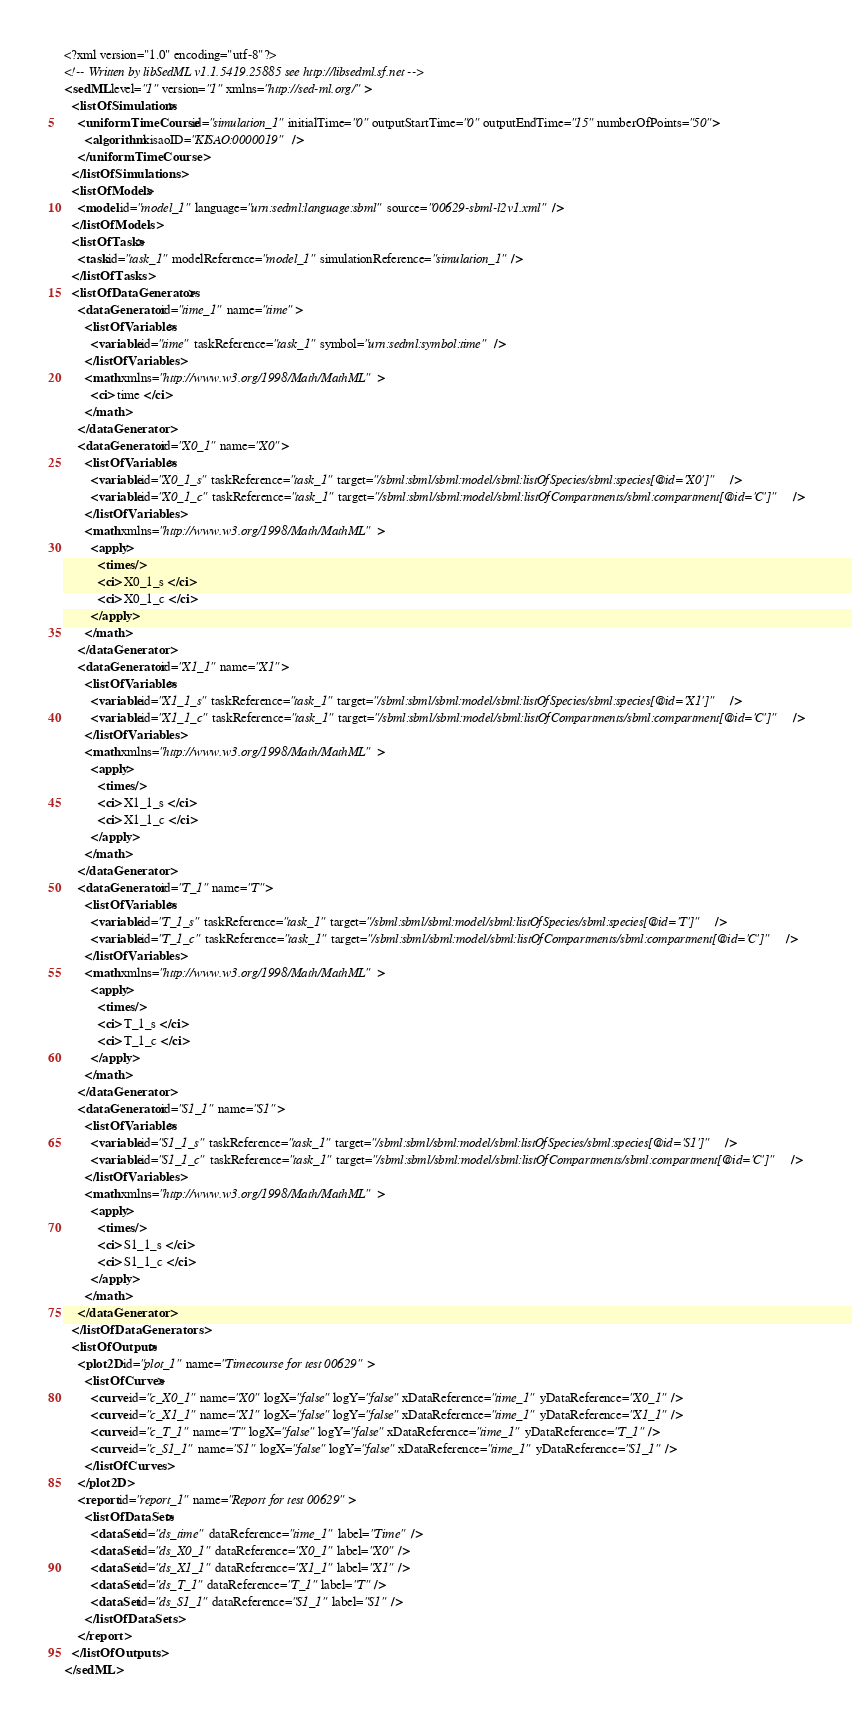Convert code to text. <code><loc_0><loc_0><loc_500><loc_500><_XML_><?xml version="1.0" encoding="utf-8"?>
<!-- Written by libSedML v1.1.5419.25885 see http://libsedml.sf.net -->
<sedML level="1" version="1" xmlns="http://sed-ml.org/">
  <listOfSimulations>
    <uniformTimeCourse id="simulation_1" initialTime="0" outputStartTime="0" outputEndTime="15" numberOfPoints="50">
      <algorithm kisaoID="KISAO:0000019" />
    </uniformTimeCourse>
  </listOfSimulations>
  <listOfModels>
    <model id="model_1" language="urn:sedml:language:sbml" source="00629-sbml-l2v1.xml" />
  </listOfModels>
  <listOfTasks>
    <task id="task_1" modelReference="model_1" simulationReference="simulation_1" />
  </listOfTasks>
  <listOfDataGenerators>
    <dataGenerator id="time_1" name="time">
      <listOfVariables>
        <variable id="time" taskReference="task_1" symbol="urn:sedml:symbol:time" />
      </listOfVariables>
      <math xmlns="http://www.w3.org/1998/Math/MathML">
        <ci> time </ci>
      </math>
    </dataGenerator>
    <dataGenerator id="X0_1" name="X0">
      <listOfVariables>
        <variable id="X0_1_s" taskReference="task_1" target="/sbml:sbml/sbml:model/sbml:listOfSpecies/sbml:species[@id='X0']" />
        <variable id="X0_1_c" taskReference="task_1" target="/sbml:sbml/sbml:model/sbml:listOfCompartments/sbml:compartment[@id='C']" />
      </listOfVariables>
      <math xmlns="http://www.w3.org/1998/Math/MathML">
        <apply>
          <times />
          <ci> X0_1_s </ci>
          <ci> X0_1_c </ci>
        </apply>
      </math>
    </dataGenerator>
    <dataGenerator id="X1_1" name="X1">
      <listOfVariables>
        <variable id="X1_1_s" taskReference="task_1" target="/sbml:sbml/sbml:model/sbml:listOfSpecies/sbml:species[@id='X1']" />
        <variable id="X1_1_c" taskReference="task_1" target="/sbml:sbml/sbml:model/sbml:listOfCompartments/sbml:compartment[@id='C']" />
      </listOfVariables>
      <math xmlns="http://www.w3.org/1998/Math/MathML">
        <apply>
          <times />
          <ci> X1_1_s </ci>
          <ci> X1_1_c </ci>
        </apply>
      </math>
    </dataGenerator>
    <dataGenerator id="T_1" name="T">
      <listOfVariables>
        <variable id="T_1_s" taskReference="task_1" target="/sbml:sbml/sbml:model/sbml:listOfSpecies/sbml:species[@id='T']" />
        <variable id="T_1_c" taskReference="task_1" target="/sbml:sbml/sbml:model/sbml:listOfCompartments/sbml:compartment[@id='C']" />
      </listOfVariables>
      <math xmlns="http://www.w3.org/1998/Math/MathML">
        <apply>
          <times />
          <ci> T_1_s </ci>
          <ci> T_1_c </ci>
        </apply>
      </math>
    </dataGenerator>
    <dataGenerator id="S1_1" name="S1">
      <listOfVariables>
        <variable id="S1_1_s" taskReference="task_1" target="/sbml:sbml/sbml:model/sbml:listOfSpecies/sbml:species[@id='S1']" />
        <variable id="S1_1_c" taskReference="task_1" target="/sbml:sbml/sbml:model/sbml:listOfCompartments/sbml:compartment[@id='C']" />
      </listOfVariables>
      <math xmlns="http://www.w3.org/1998/Math/MathML">
        <apply>
          <times />
          <ci> S1_1_s </ci>
          <ci> S1_1_c </ci>
        </apply>
      </math>
    </dataGenerator>
  </listOfDataGenerators>
  <listOfOutputs>
    <plot2D id="plot_1" name="Timecourse for test 00629">
      <listOfCurves>
        <curve id="c_X0_1" name="X0" logX="false" logY="false" xDataReference="time_1" yDataReference="X0_1" />
        <curve id="c_X1_1" name="X1" logX="false" logY="false" xDataReference="time_1" yDataReference="X1_1" />
        <curve id="c_T_1" name="T" logX="false" logY="false" xDataReference="time_1" yDataReference="T_1" />
        <curve id="c_S1_1" name="S1" logX="false" logY="false" xDataReference="time_1" yDataReference="S1_1" />
      </listOfCurves>
    </plot2D>
    <report id="report_1" name="Report for test 00629">
      <listOfDataSets>
        <dataSet id="ds_time" dataReference="time_1" label="Time" />
        <dataSet id="ds_X0_1" dataReference="X0_1" label="X0" />
        <dataSet id="ds_X1_1" dataReference="X1_1" label="X1" />
        <dataSet id="ds_T_1" dataReference="T_1" label="T" />
        <dataSet id="ds_S1_1" dataReference="S1_1" label="S1" />
      </listOfDataSets>
    </report>
  </listOfOutputs>
</sedML></code> 